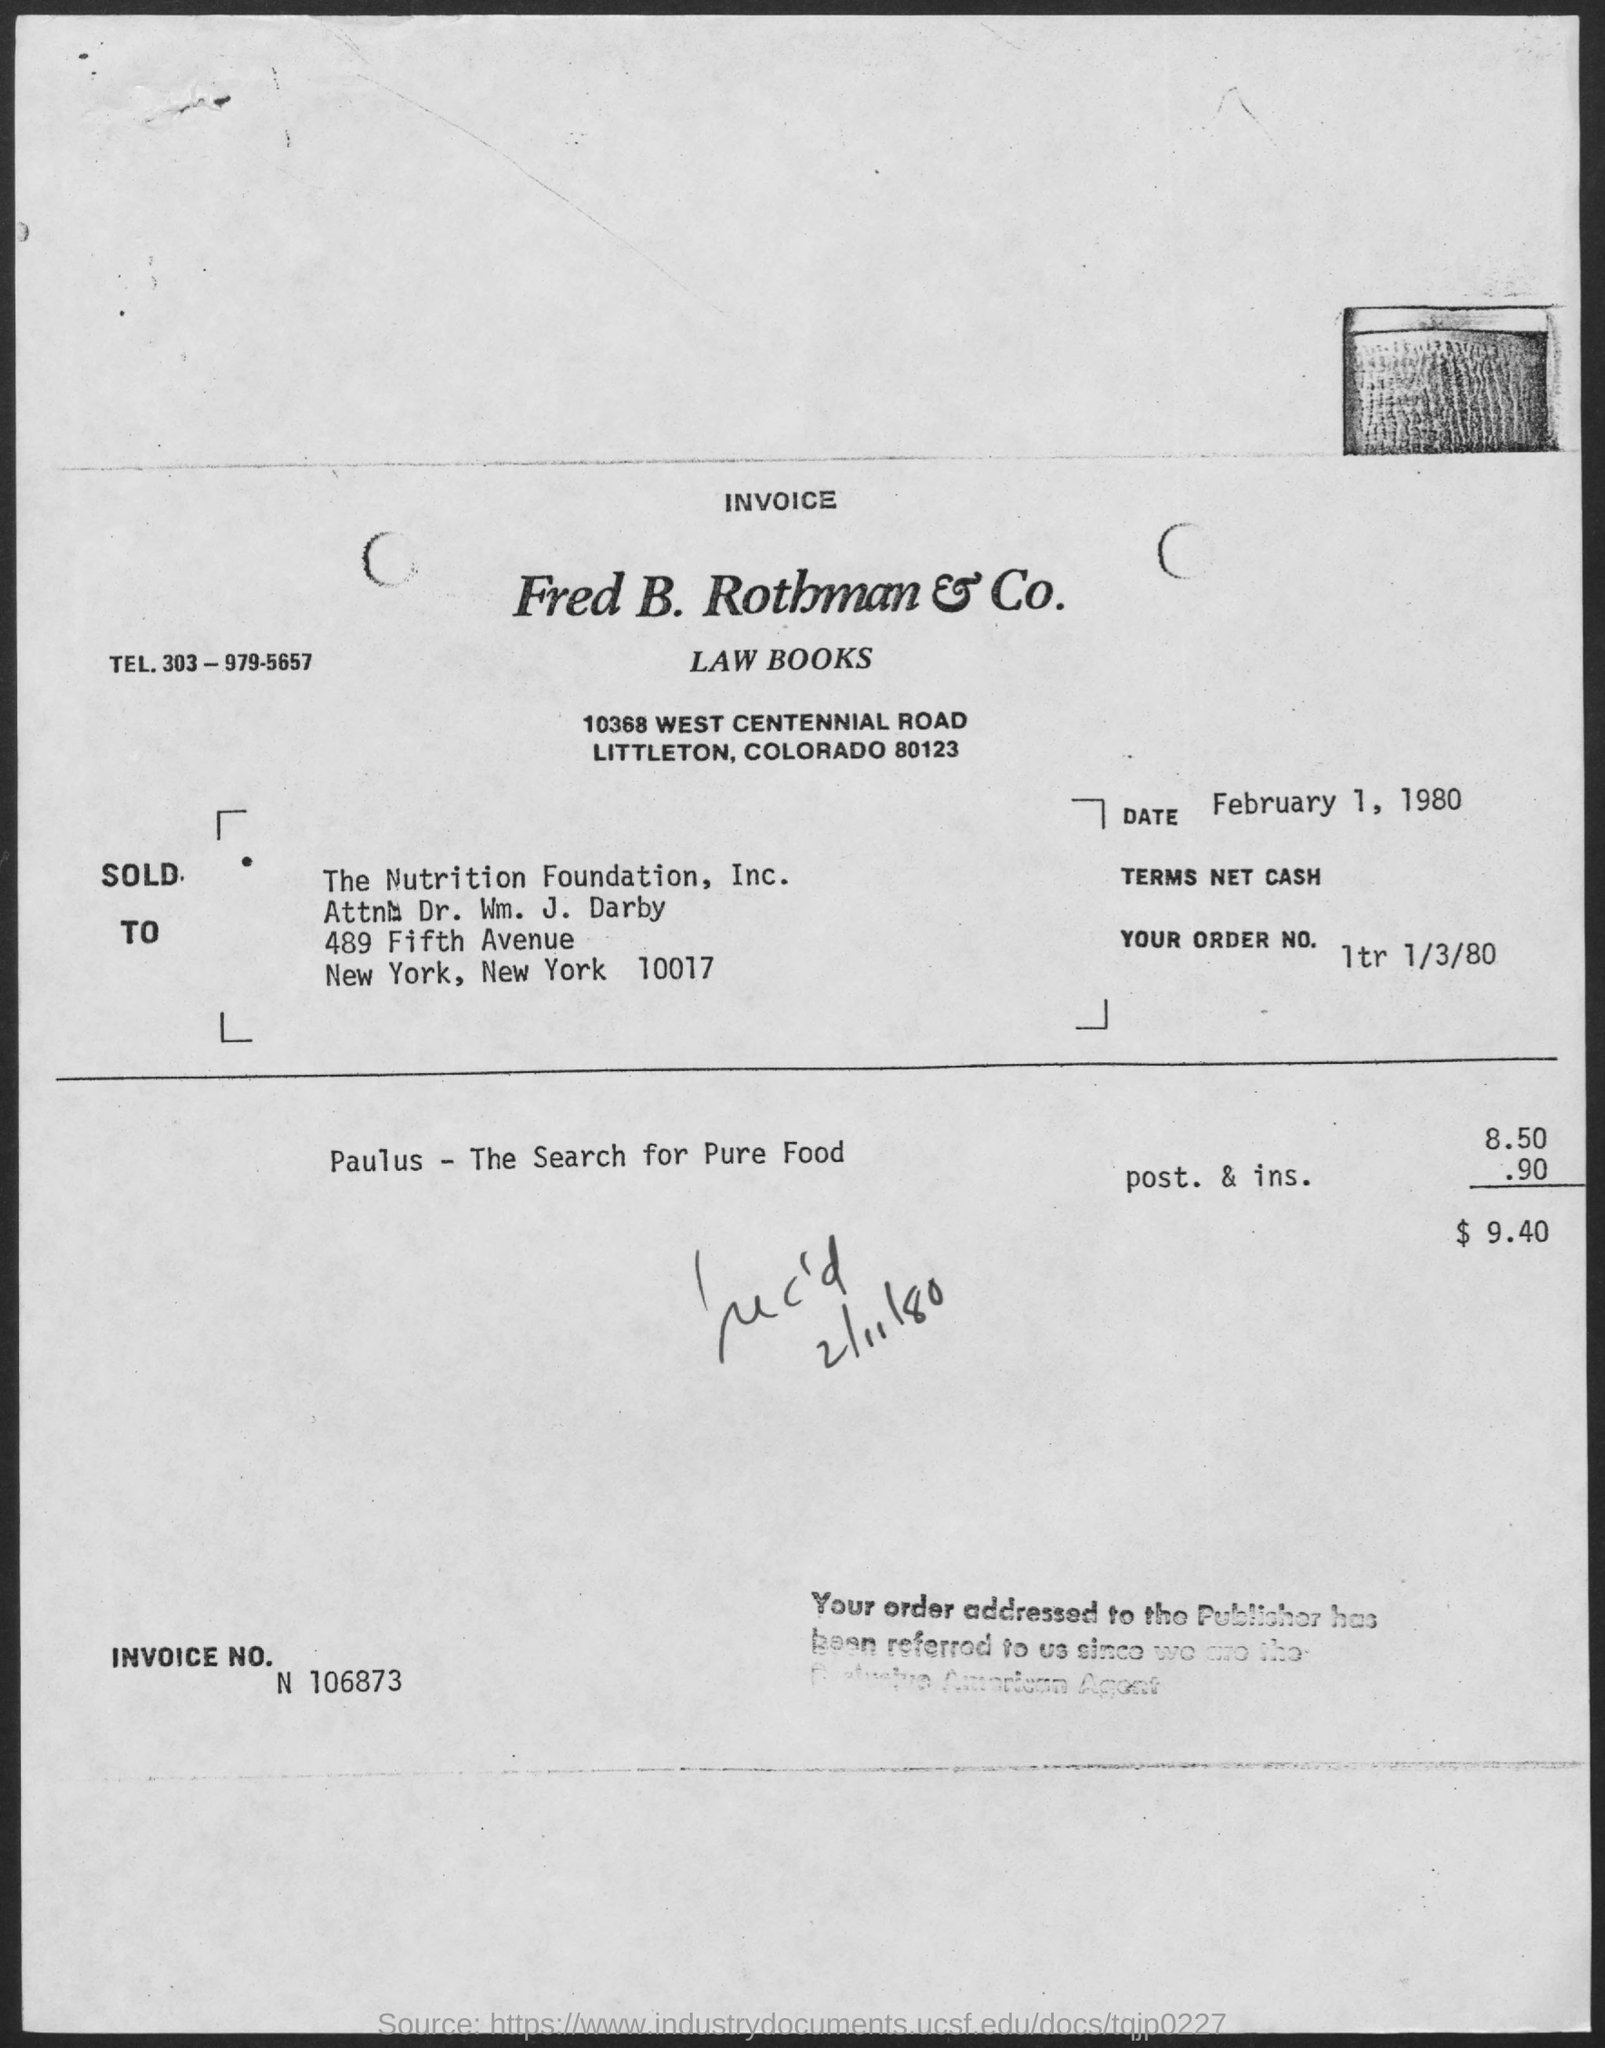Identify some key points in this picture. The total amount is 9.40. The document indicates that the date is February 1, 1980. This is the invoice number N 106873... 